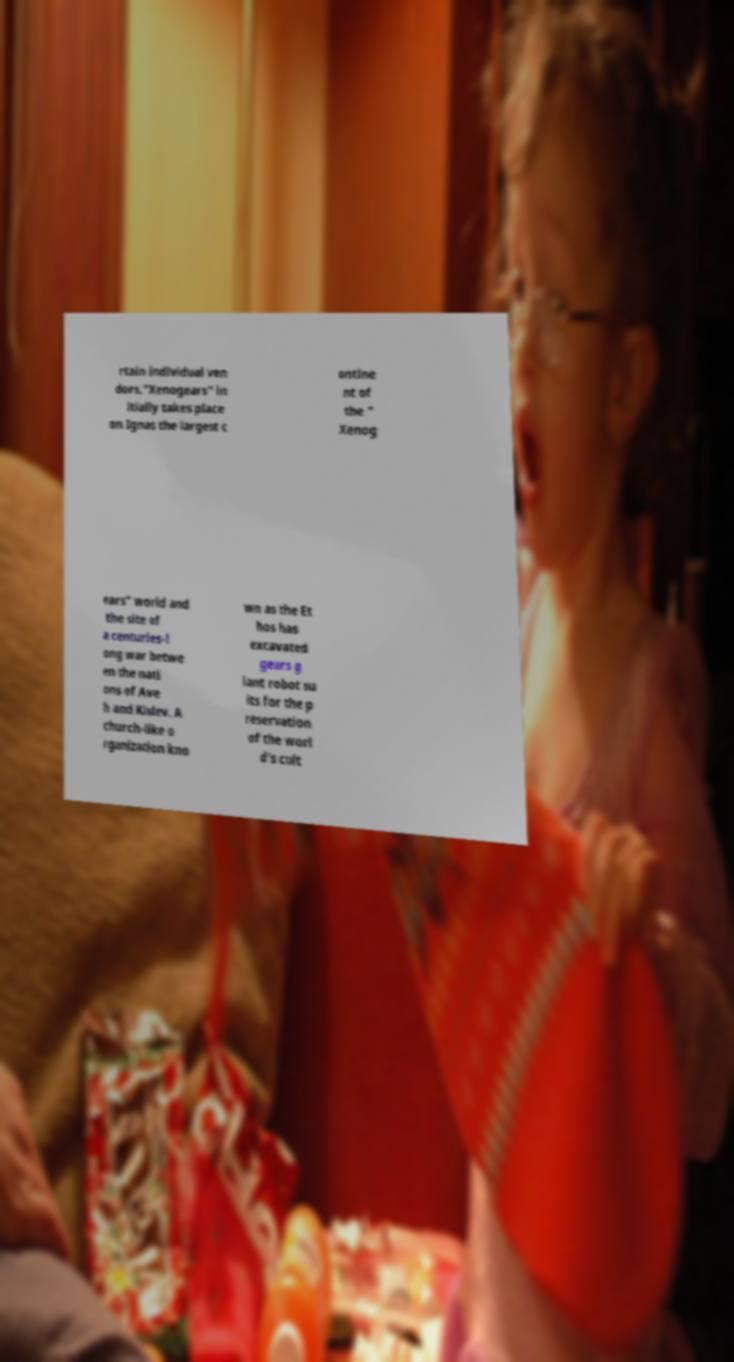Can you read and provide the text displayed in the image?This photo seems to have some interesting text. Can you extract and type it out for me? rtain individual ven dors."Xenogears" in itially takes place on Ignas the largest c ontine nt of the " Xenog ears" world and the site of a centuries-l ong war betwe en the nati ons of Ave h and Kislev. A church-like o rganization kno wn as the Et hos has excavated gears g iant robot su its for the p reservation of the worl d's cult 